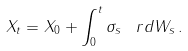<formula> <loc_0><loc_0><loc_500><loc_500>X _ { t } = X _ { 0 } + \int _ { 0 } ^ { t } \sigma _ { s } \, \ r d W _ { s } \, .</formula> 